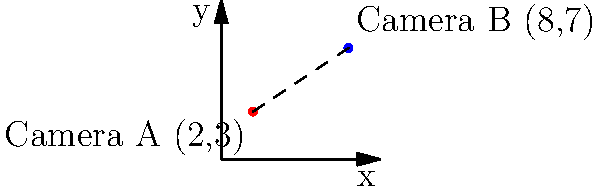In a pivotal scene from Sam Mendes' "1917", two camera positions are marked on a coordinate plane. Camera A is located at point (2,3) and Camera B is at point (8,7). Calculate the distance between these two camera positions to determine the length of the tracking shot. To find the distance between two points on a coordinate plane, we can use the distance formula, which is derived from the Pythagorean theorem:

$$ d = \sqrt{(x_2 - x_1)^2 + (y_2 - y_1)^2} $$

Where $(x_1, y_1)$ represents the coordinates of the first point and $(x_2, y_2)$ represents the coordinates of the second point.

Let's plug in our values:
- Camera A: $(x_1, y_1) = (2, 3)$
- Camera B: $(x_2, y_2) = (8, 7)$

Now, let's calculate:

1) First, find the differences:
   $x_2 - x_1 = 8 - 2 = 6$
   $y_2 - y_1 = 7 - 3 = 4$

2) Square these differences:
   $(x_2 - x_1)^2 = 6^2 = 36$
   $(y_2 - y_1)^2 = 4^2 = 16$

3) Add these squared differences:
   $36 + 16 = 52$

4) Take the square root of this sum:
   $d = \sqrt{52}$

5) Simplify:
   $d = \sqrt{4 \times 13} = 2\sqrt{13}$

Therefore, the distance between the two camera positions is $2\sqrt{13}$ units.
Answer: $2\sqrt{13}$ units 